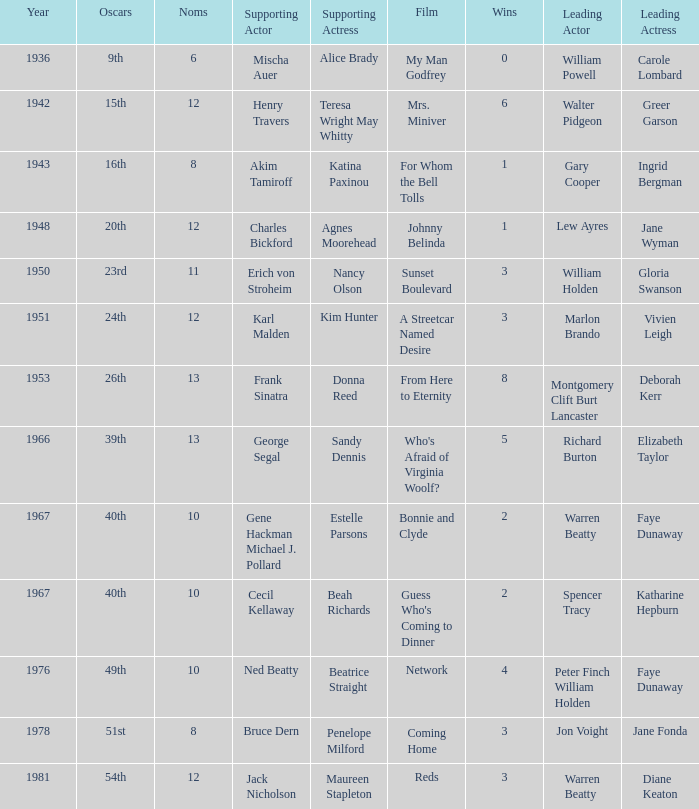Who was the supporting actress in 1943? Katina Paxinou. 